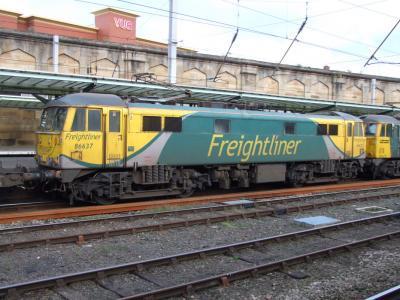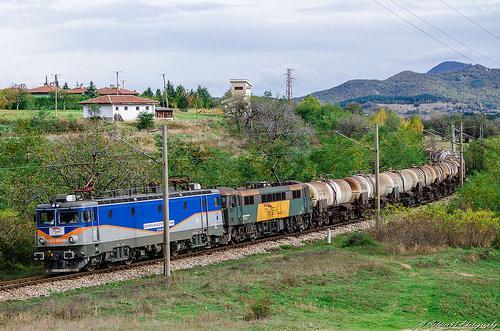The first image is the image on the left, the second image is the image on the right. Given the left and right images, does the statement "The train in one of the images has just come around a bend." hold true? Answer yes or no. Yes. The first image is the image on the left, the second image is the image on the right. Analyze the images presented: Is the assertion "The train in the right image is painted yellow in the front." valid? Answer yes or no. No. 